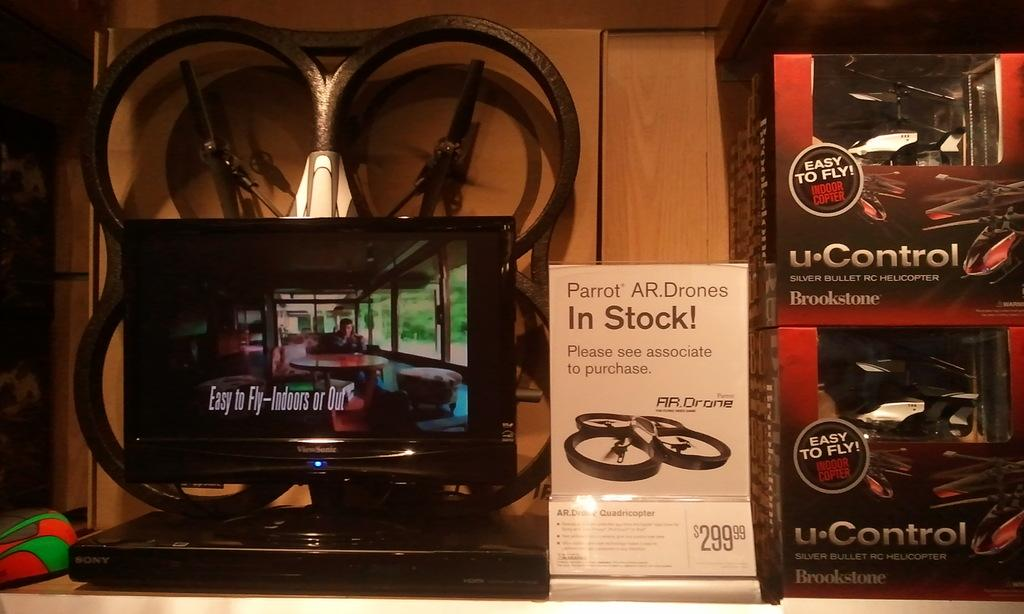<image>
Present a compact description of the photo's key features. A banner advertises that Parrot AR Drones are in stock and cost $299.99 